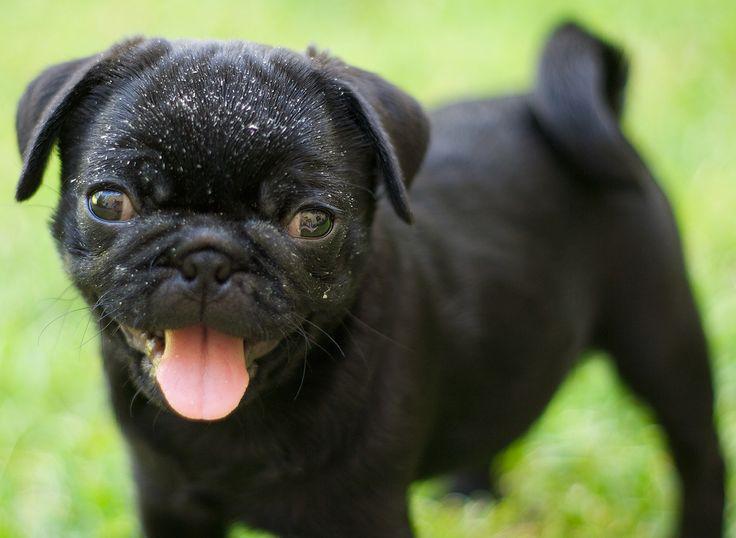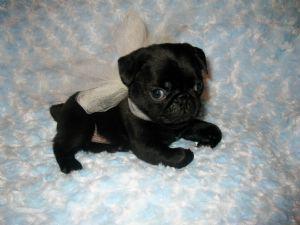The first image is the image on the left, the second image is the image on the right. Examine the images to the left and right. Is the description "An image shows one black pug, with its tongue out." accurate? Answer yes or no. Yes. The first image is the image on the left, the second image is the image on the right. For the images displayed, is the sentence "One of the dogs is standing in the grass." factually correct? Answer yes or no. Yes. 